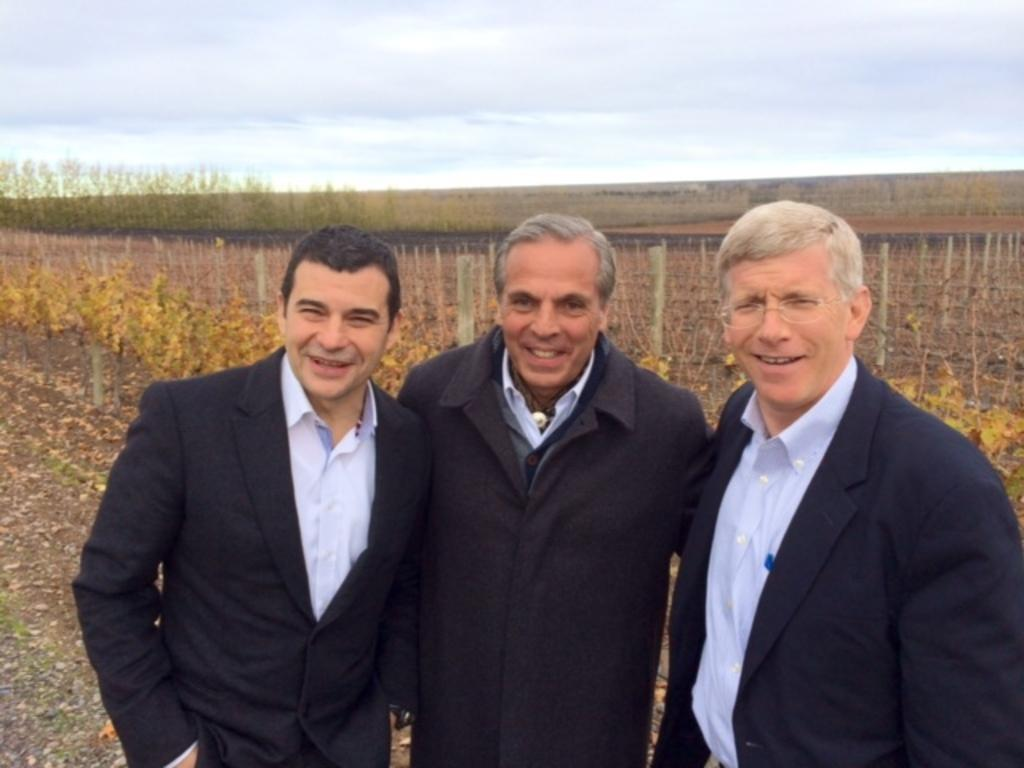How many people are in the image? There are three people standing in the image. What is located behind the people? There is a fence visible behind the people. What can be seen in the background of the image? Trees and the sky are visible in the background of the image. What verse is being recited by the people in the image? There is no indication in the image that the people are reciting a verse, so it cannot be determined from the picture. 